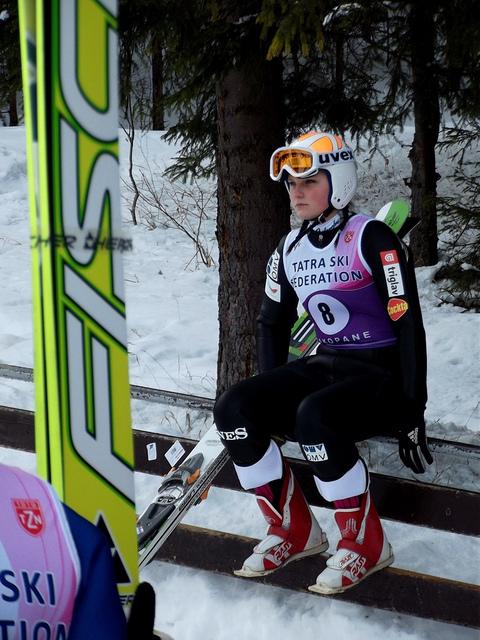What group is sponsoring this skier?
Be succinct. Tatra ski federation. Is the woman nervous?
Give a very brief answer. Yes. What number is she?
Concise answer only. 8. 